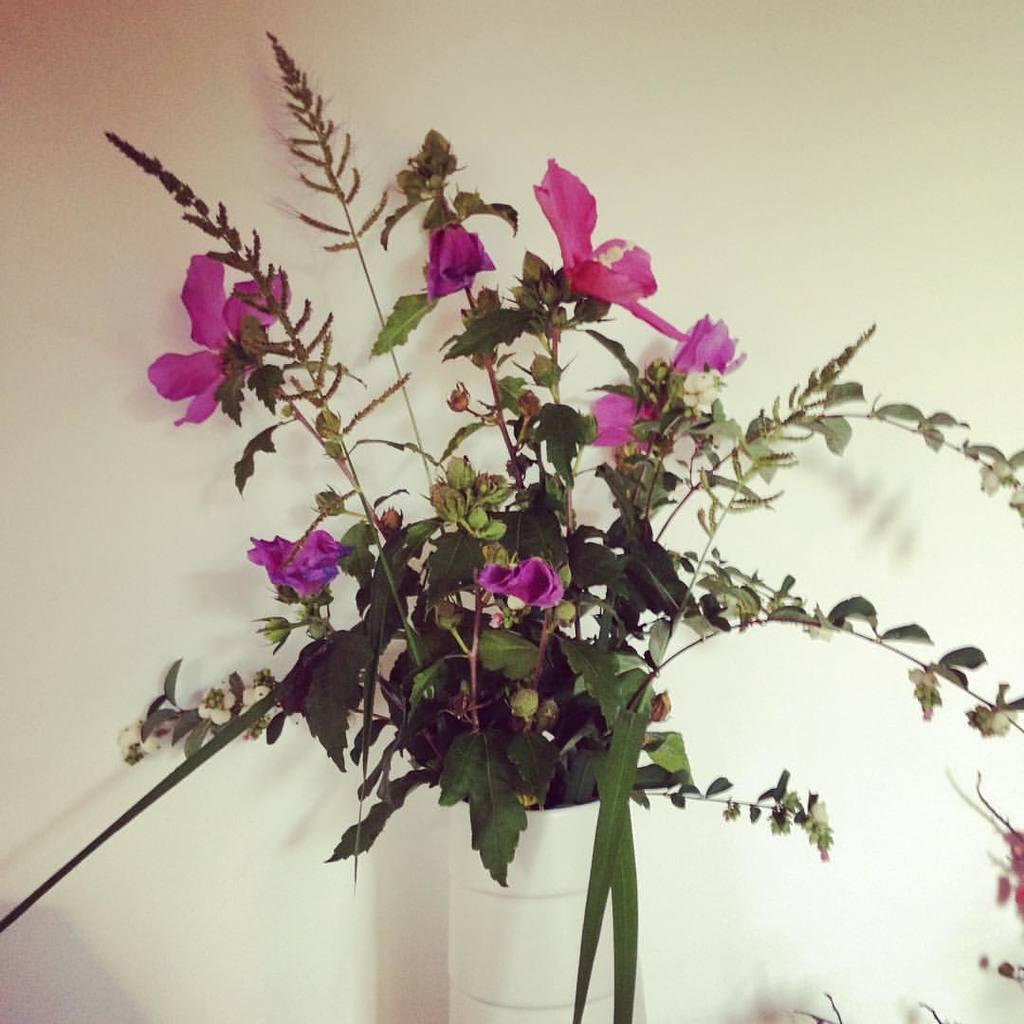Describe this image in one or two sentences. In this image we can see some flowers, and a house plant, also we can see the wall. 